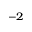Convert formula to latex. <formula><loc_0><loc_0><loc_500><loc_500>^ { - 2 }</formula> 